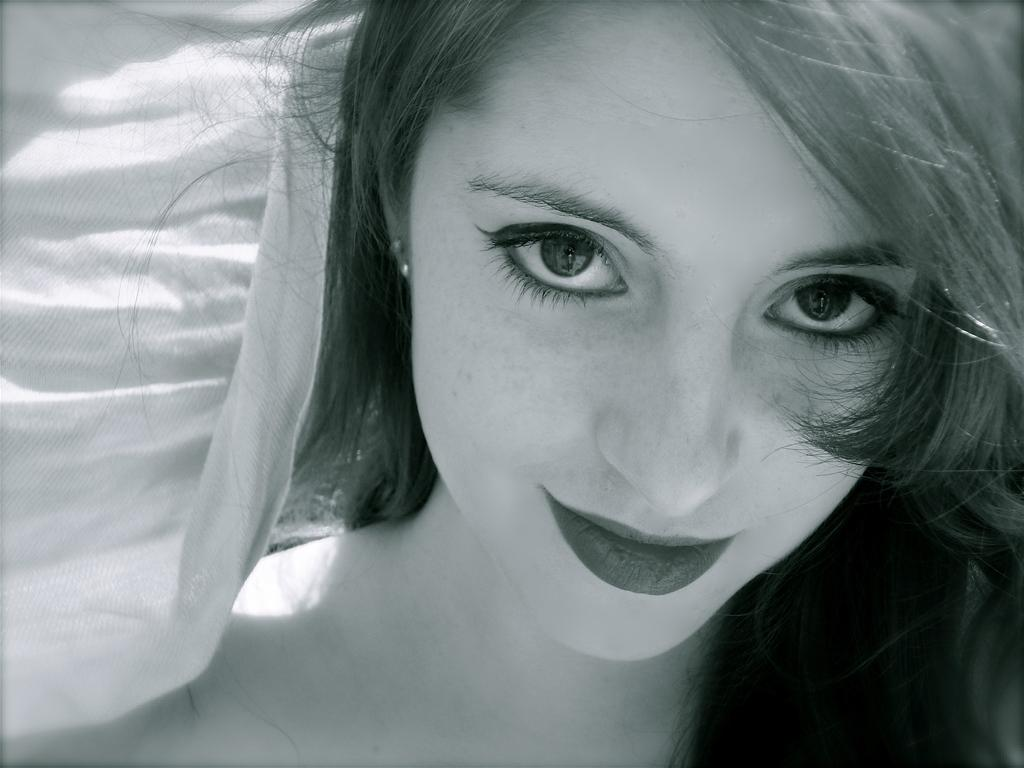What is the main subject of the image? The main subject of the image is a woman's face. What color scheme is used in the image? The image is black and white in color. What type of crayon is the woman holding in the image? There is no crayon present in the image, and the woman's hands are not visible. Can you tell me how the father is interacting with the woman in the image? There is no father present in the image, and the woman is the only person visible. 